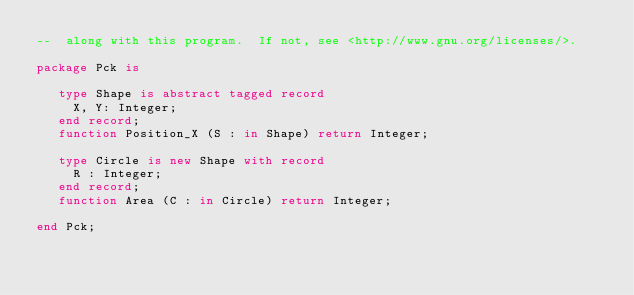Convert code to text. <code><loc_0><loc_0><loc_500><loc_500><_Ada_>--  along with this program.  If not, see <http://www.gnu.org/licenses/>.

package Pck is

   type Shape is abstract tagged record
     X, Y: Integer;
   end record;
   function Position_X (S : in Shape) return Integer;

   type Circle is new Shape with record
     R : Integer;
   end record;
   function Area (C : in Circle) return Integer;

end Pck;

</code> 